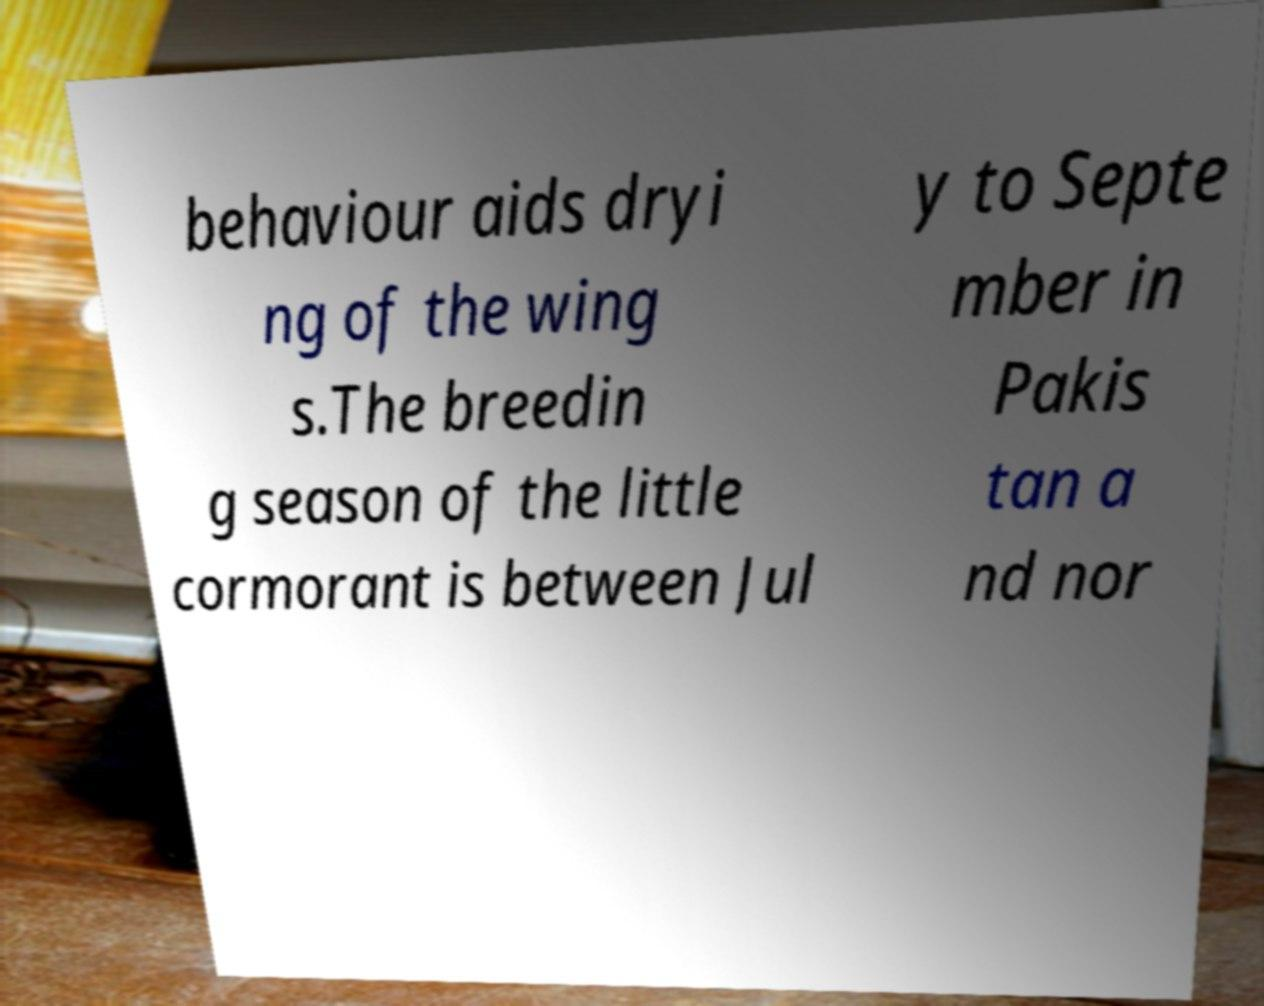Please read and relay the text visible in this image. What does it say? behaviour aids dryi ng of the wing s.The breedin g season of the little cormorant is between Jul y to Septe mber in Pakis tan a nd nor 